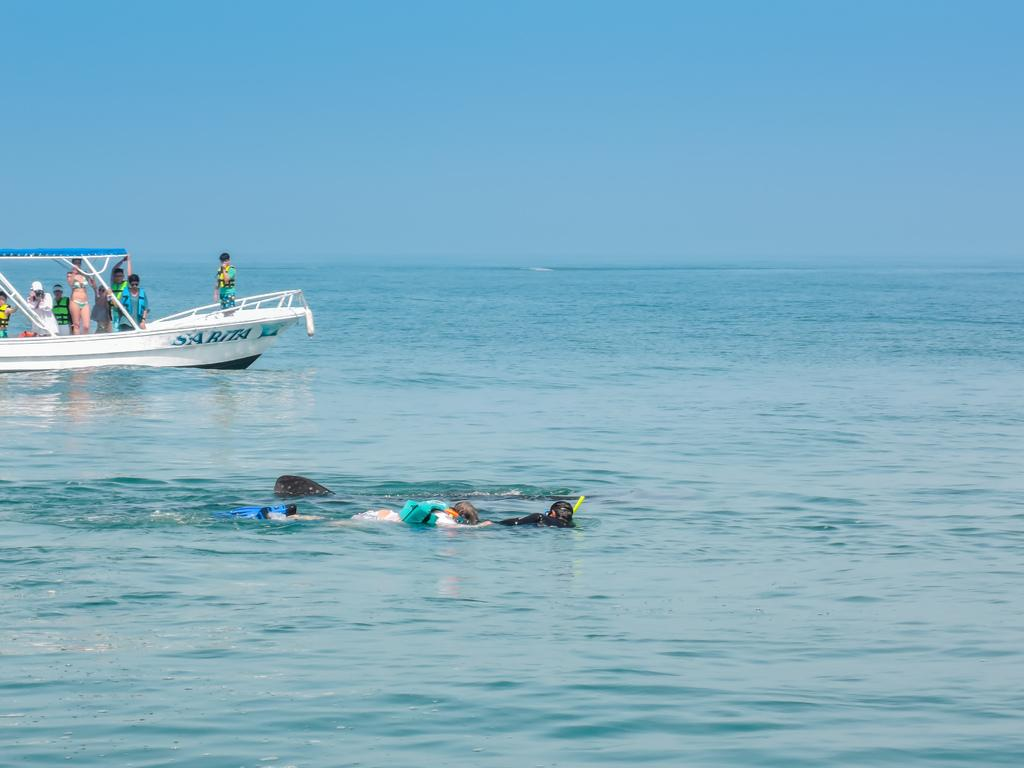What is the main subject of the image? The main subject of the image is a boat. Where is the boat located? The boat is on water. Are there any people in the boat? Yes, there are people in the boat. What else can be seen in the image besides the boat and people? There are people swimming in the image. What type of vessel is being used for sorting in the image? There is no vessel or sorting activity present in the image; it features a boat on water with people in it and people swimming. 